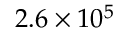Convert formula to latex. <formula><loc_0><loc_0><loc_500><loc_500>2 . 6 \times 1 0 ^ { 5 }</formula> 